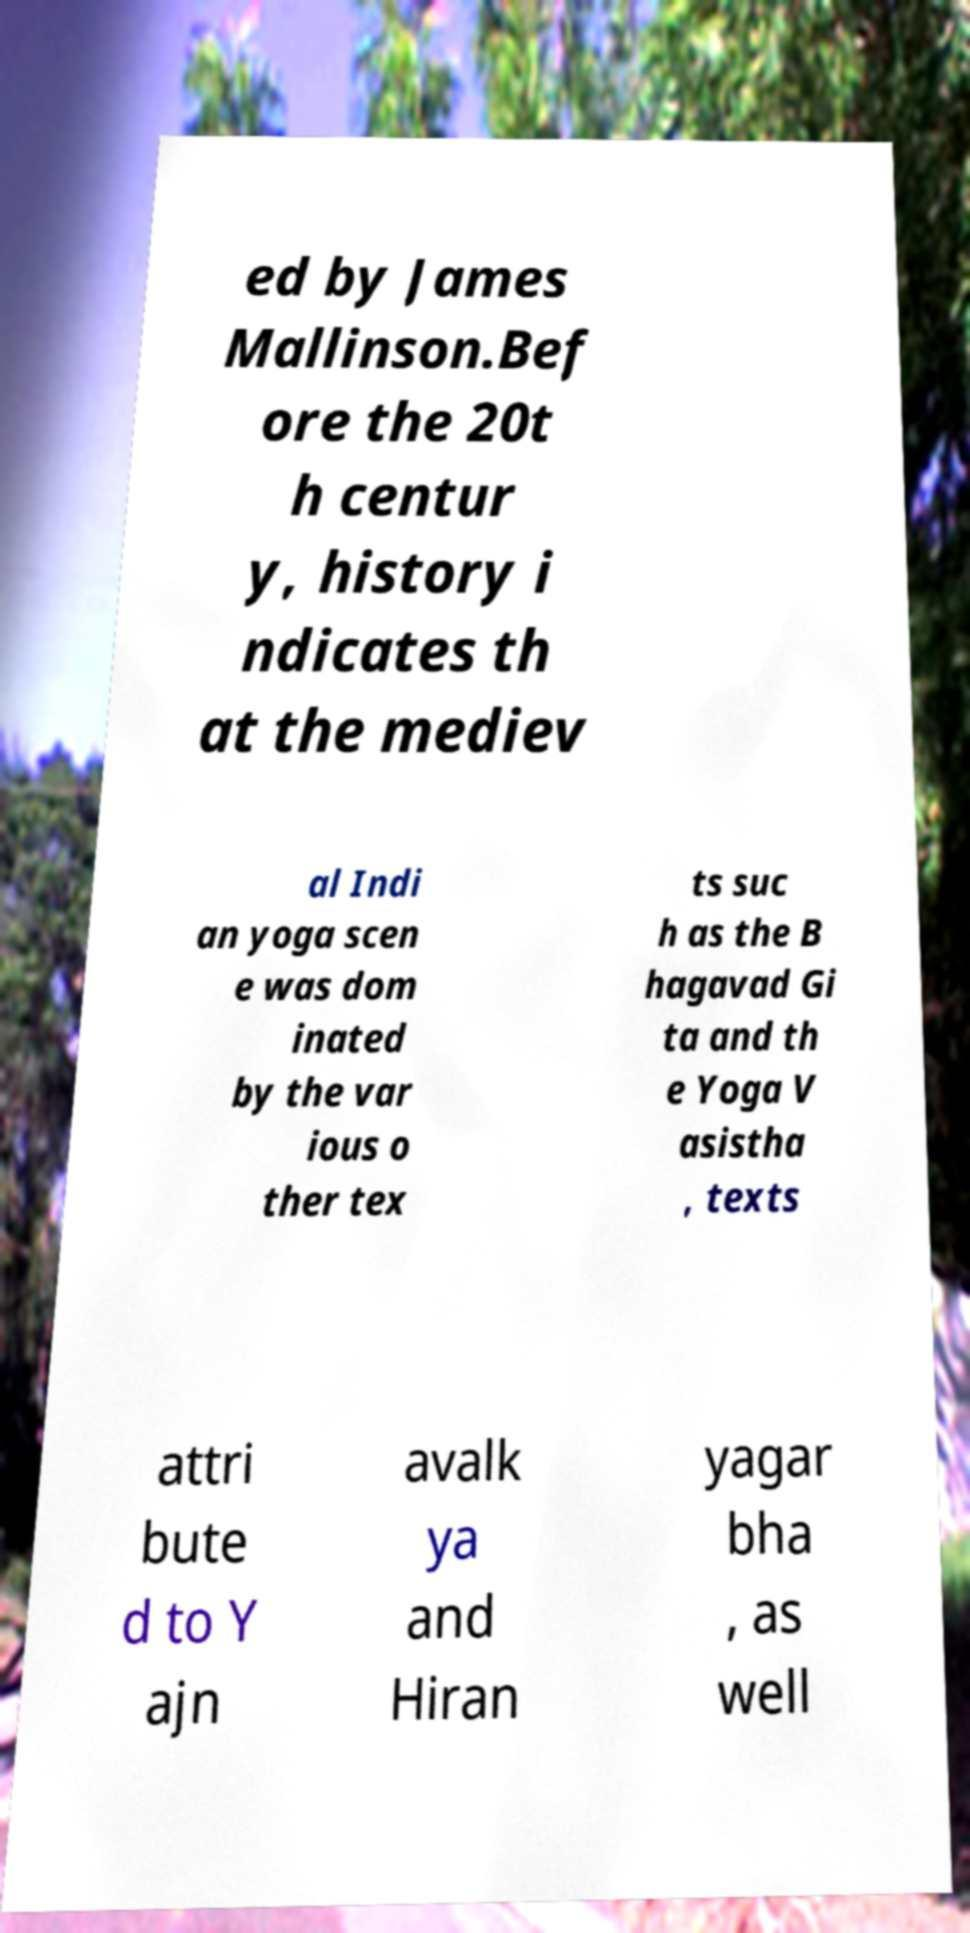Please read and relay the text visible in this image. What does it say? ed by James Mallinson.Bef ore the 20t h centur y, history i ndicates th at the mediev al Indi an yoga scen e was dom inated by the var ious o ther tex ts suc h as the B hagavad Gi ta and th e Yoga V asistha , texts attri bute d to Y ajn avalk ya and Hiran yagar bha , as well 